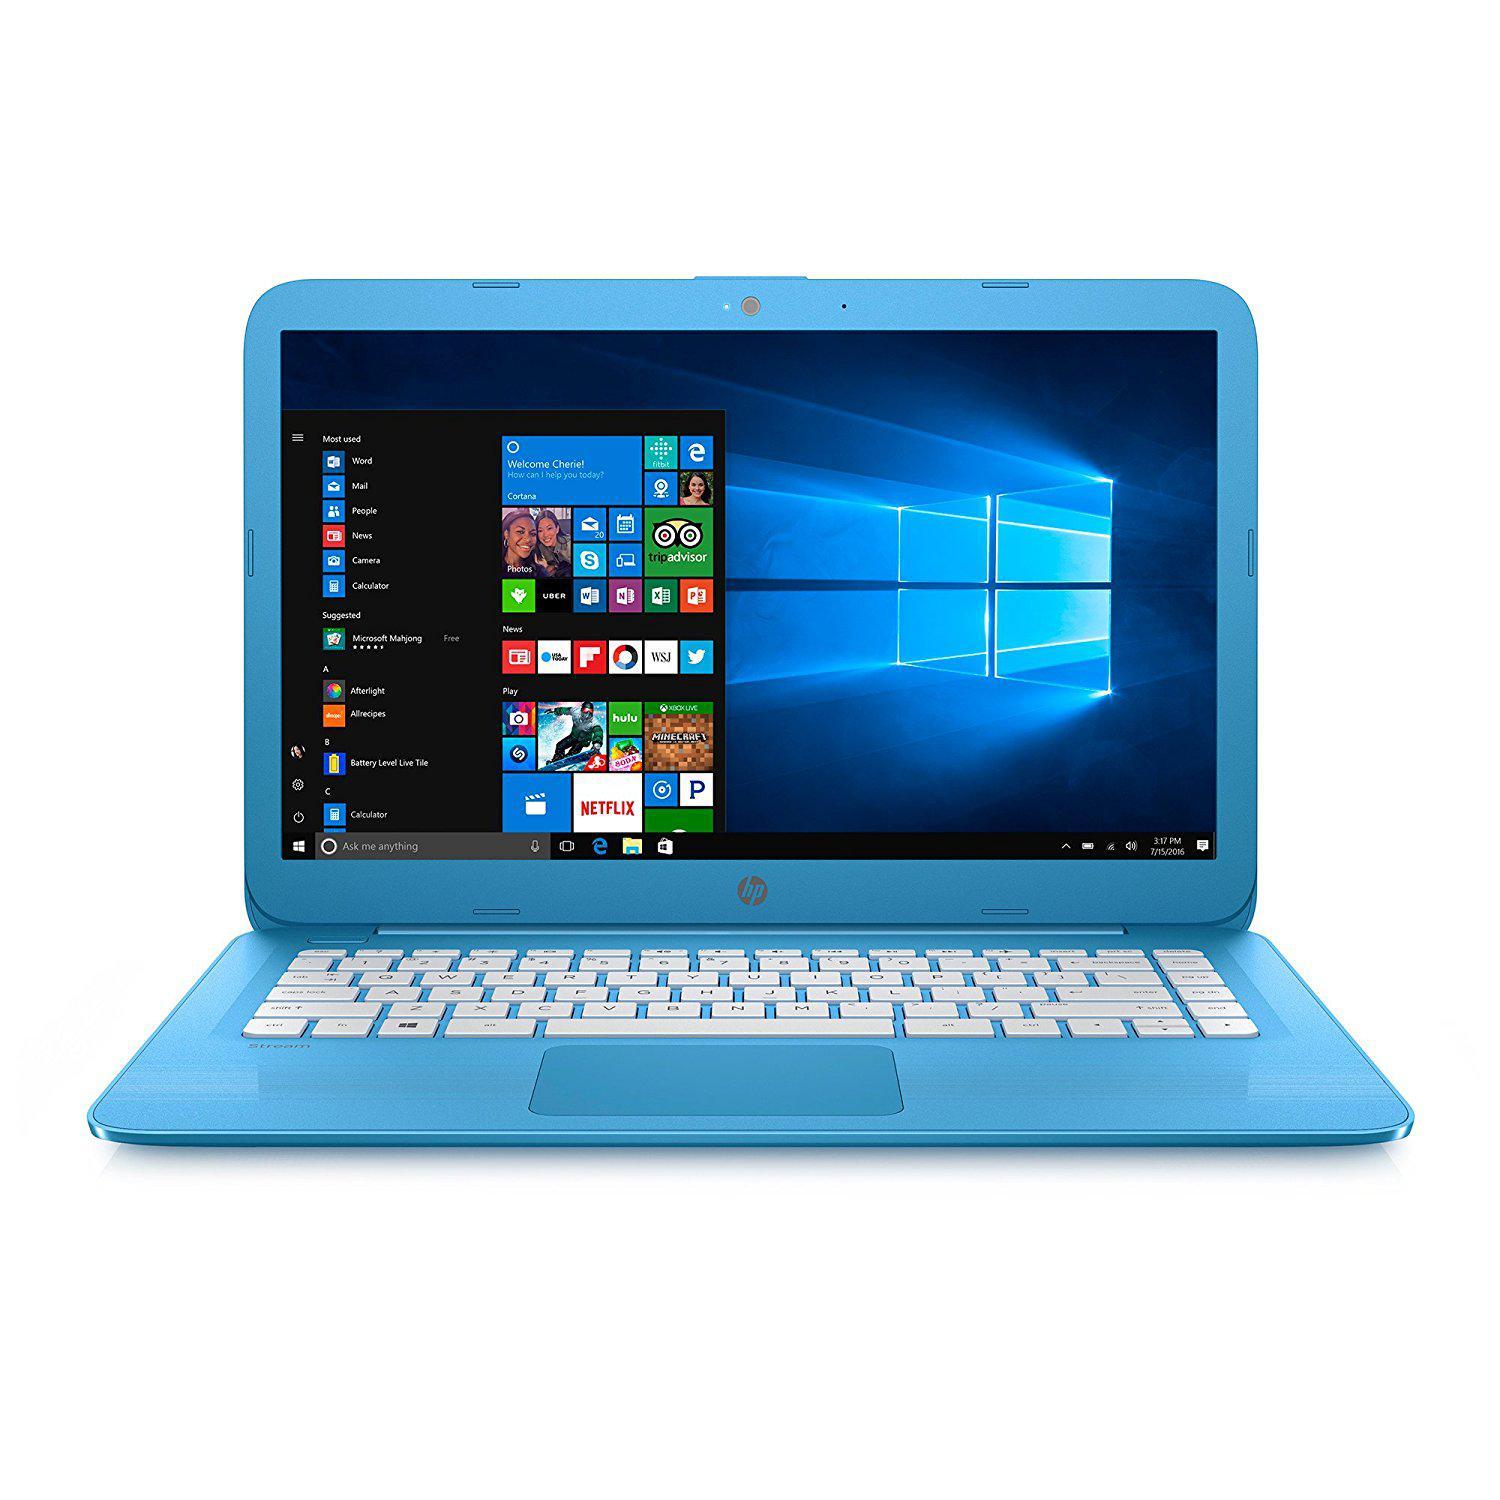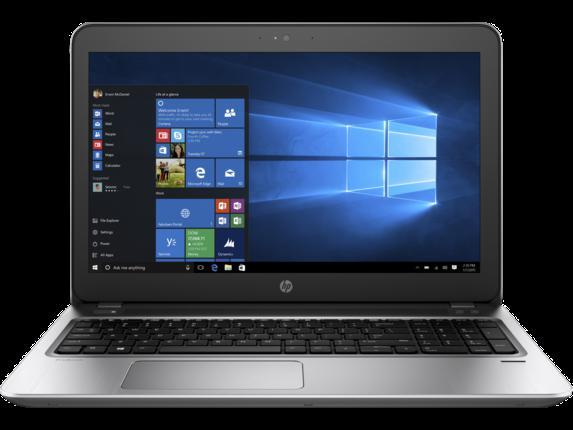The first image is the image on the left, the second image is the image on the right. For the images shown, is this caption "the laptop on the right image has a black background" true? Answer yes or no. Yes. 